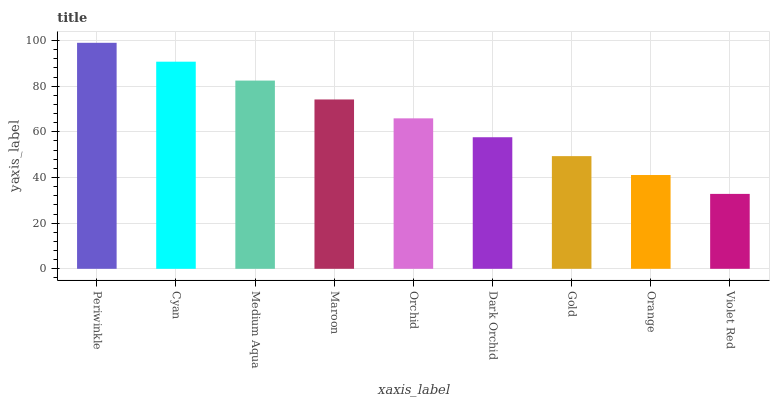Is Cyan the minimum?
Answer yes or no. No. Is Cyan the maximum?
Answer yes or no. No. Is Periwinkle greater than Cyan?
Answer yes or no. Yes. Is Cyan less than Periwinkle?
Answer yes or no. Yes. Is Cyan greater than Periwinkle?
Answer yes or no. No. Is Periwinkle less than Cyan?
Answer yes or no. No. Is Orchid the high median?
Answer yes or no. Yes. Is Orchid the low median?
Answer yes or no. Yes. Is Violet Red the high median?
Answer yes or no. No. Is Gold the low median?
Answer yes or no. No. 